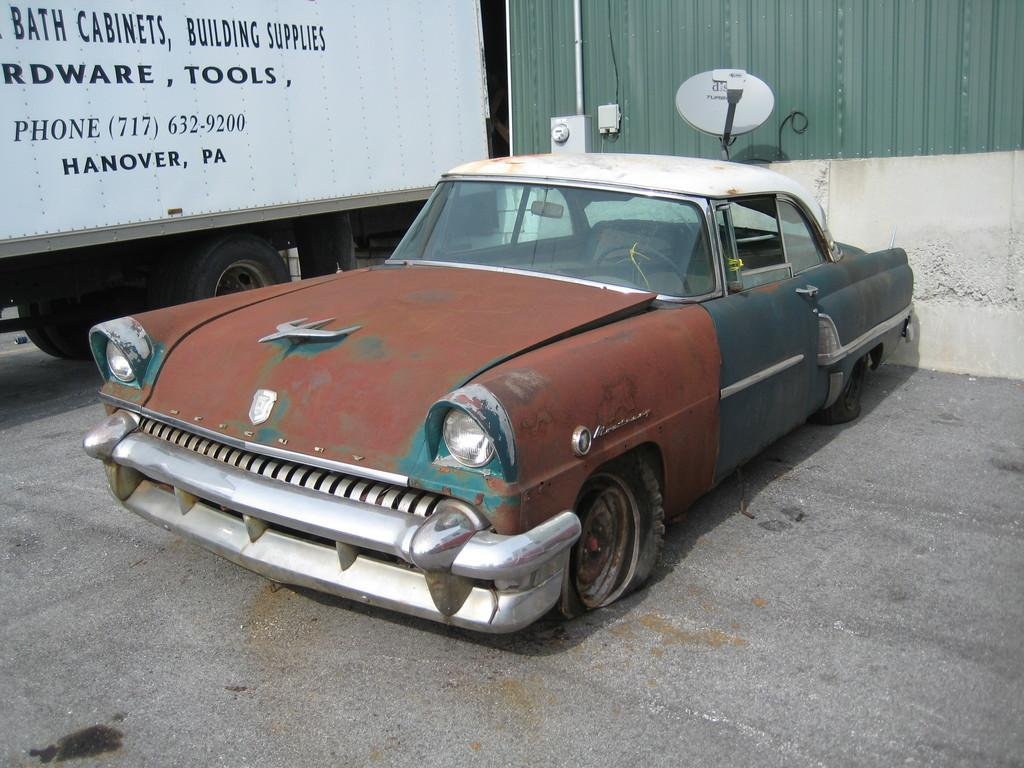What type of vehicle is the main subject in the image? There is an old vintage car in the image. What other vehicle can be seen in the image? There is a truck with a white color box in the image. What is visible in the background of the image? There is a wall with a dish in the background of the image. What type of zipper can be seen on the vintage car in the image? There is no zipper present on the vintage car in the image. What type of system is being used to transport the white color box in the image? The image does not provide information about the transportation system used for the white color box; it only shows a truck with the box. 